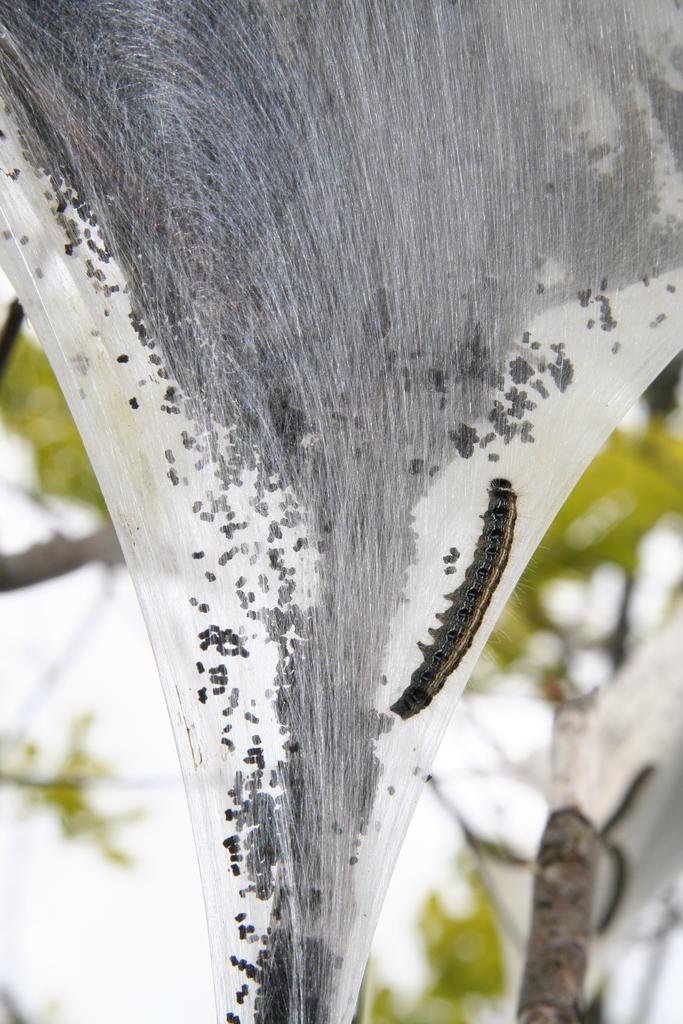Describe this image in one or two sentences. In this picture we can see a tent caterpillar. Behind the tent caterpillar, there is a blurred background. 